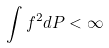<formula> <loc_0><loc_0><loc_500><loc_500>\int f ^ { 2 } d P < \infty</formula> 